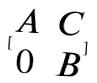Convert formula to latex. <formula><loc_0><loc_0><loc_500><loc_500>[ \begin{matrix} A & C \\ 0 & B \end{matrix} ]</formula> 